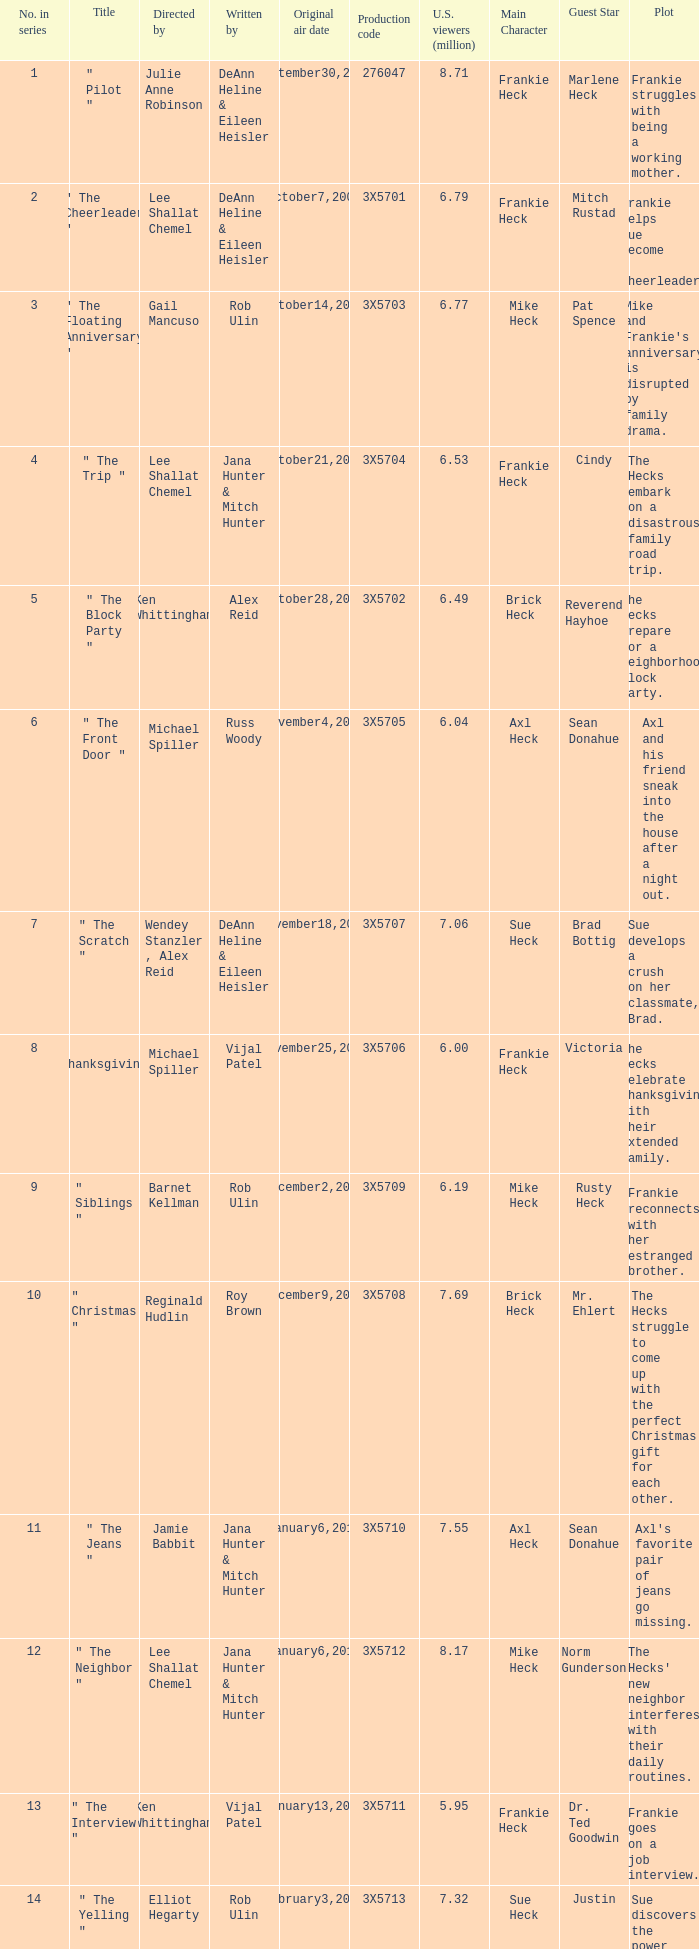95 million u.s. viewers? Vijal Patel. 